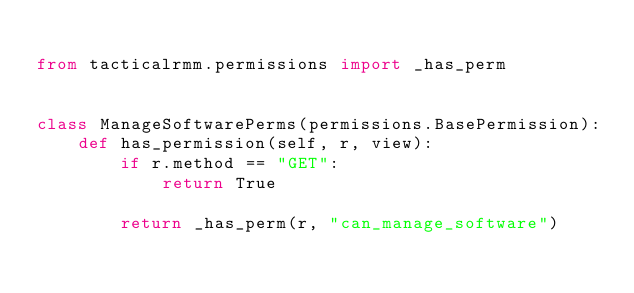Convert code to text. <code><loc_0><loc_0><loc_500><loc_500><_Python_>
from tacticalrmm.permissions import _has_perm


class ManageSoftwarePerms(permissions.BasePermission):
    def has_permission(self, r, view):
        if r.method == "GET":
            return True

        return _has_perm(r, "can_manage_software")
</code> 